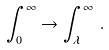Convert formula to latex. <formula><loc_0><loc_0><loc_500><loc_500>\int _ { 0 } ^ { \infty } \rightarrow \int _ { \lambda } ^ { \infty } \, .</formula> 